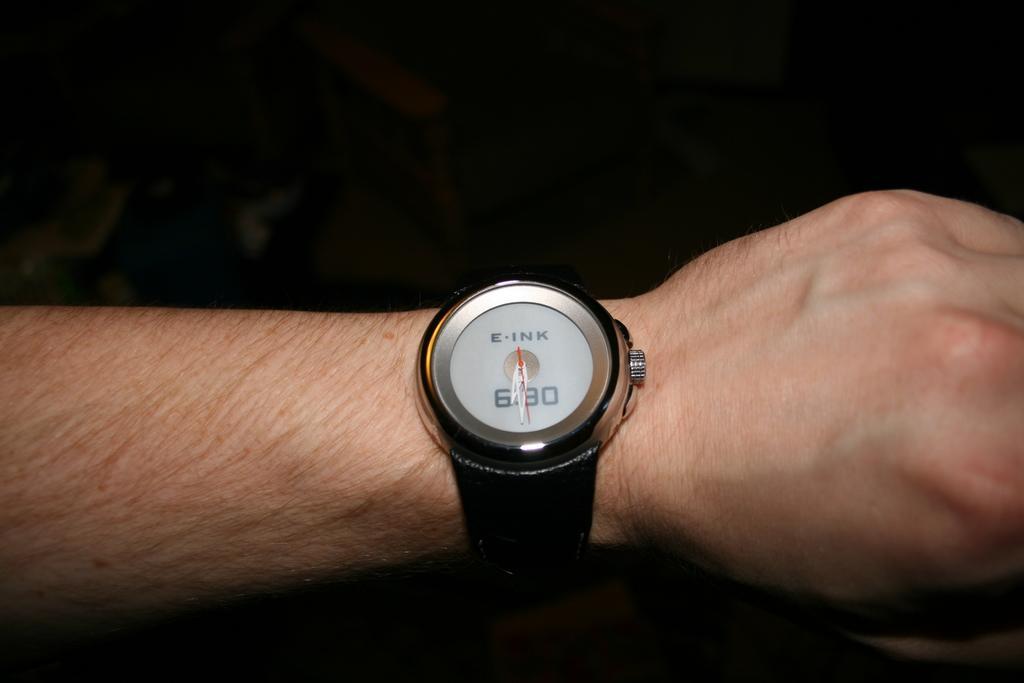Please provide a concise description of this image. In this image we can see a person's hand wearing a wrist watch. 